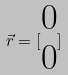<formula> <loc_0><loc_0><loc_500><loc_500>\vec { r } = [ \begin{matrix} 0 \\ 0 \end{matrix} ]</formula> 